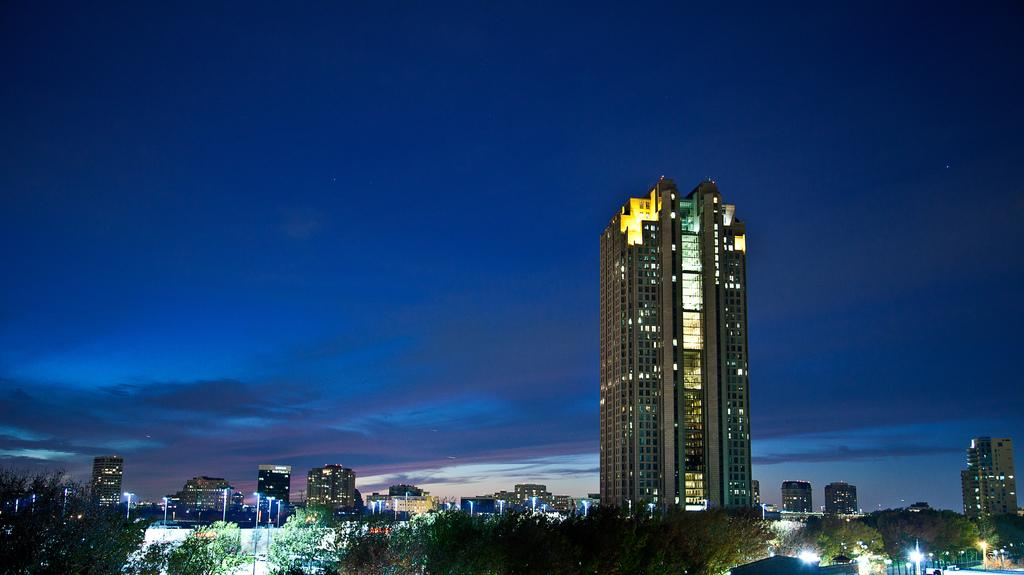What type of structures are visible in the image? There are buildings with lights in the image. What other natural elements can be seen in the image? There are trees in the image. What are the lights attached to on the ground? The lights are attached to poles on the ground. What is visible in the background of the image? In the background, there are clouds in the blue sky. Can you see any fish swimming in the image? There are no fish visible in the image; it features buildings, trees, lights, and a sky with clouds. 